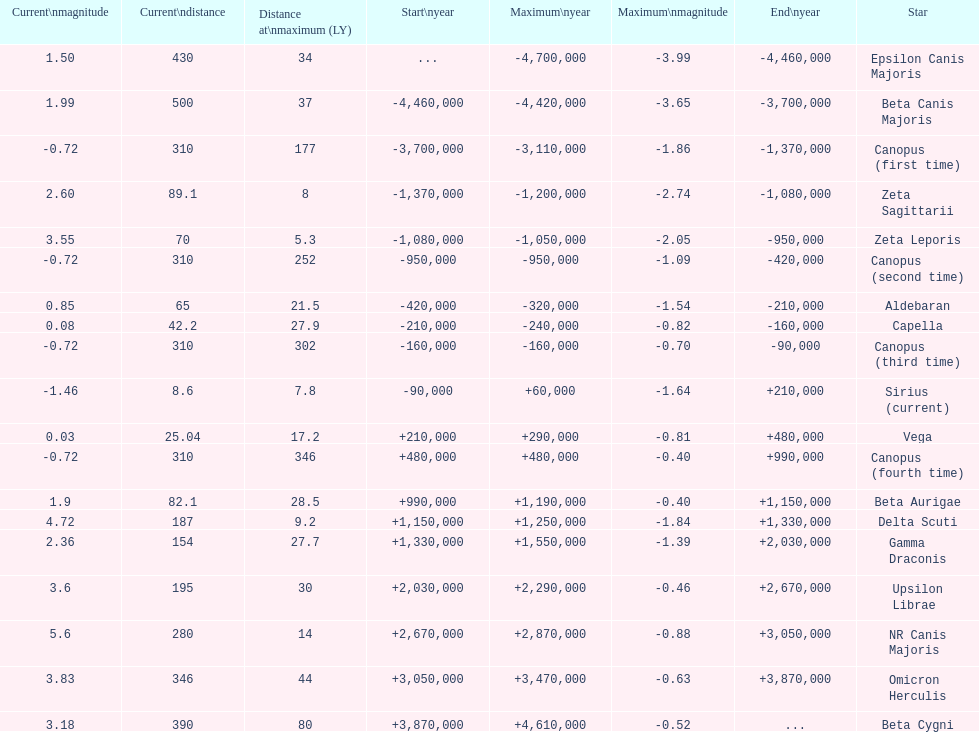How much farther (in ly) is epsilon canis majoris than zeta sagittarii? 26. 